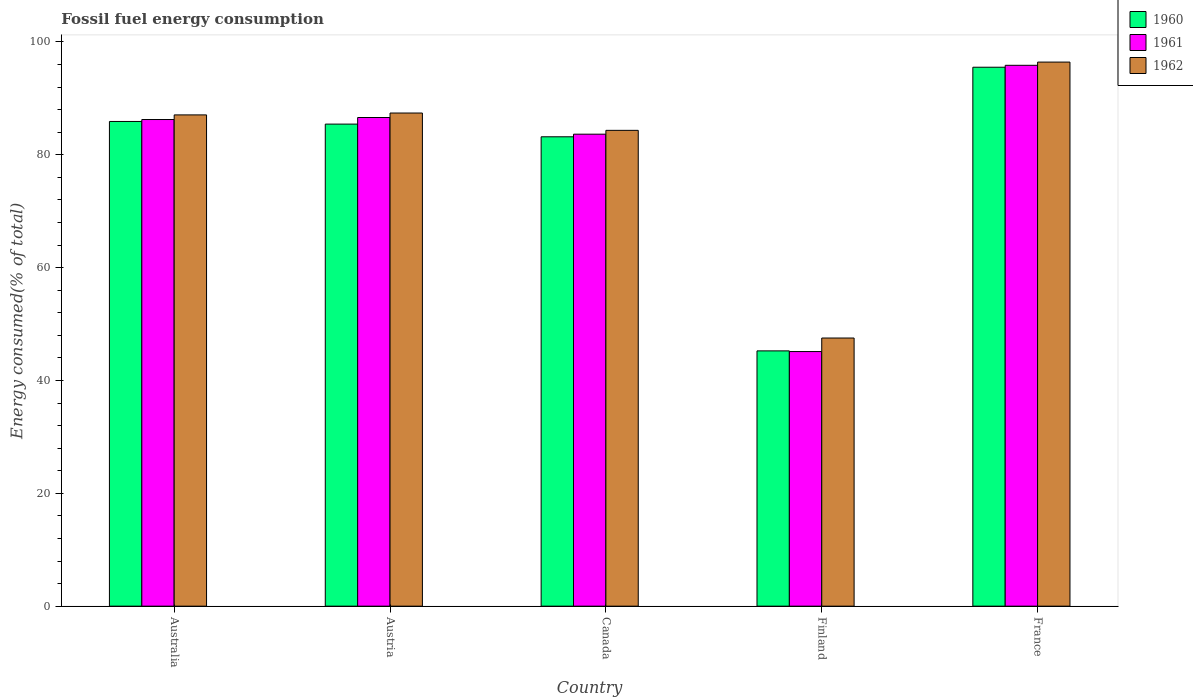How many different coloured bars are there?
Offer a very short reply. 3. Are the number of bars per tick equal to the number of legend labels?
Your response must be concise. Yes. What is the percentage of energy consumed in 1962 in France?
Your answer should be very brief. 96.43. Across all countries, what is the maximum percentage of energy consumed in 1961?
Offer a very short reply. 95.86. Across all countries, what is the minimum percentage of energy consumed in 1961?
Give a very brief answer. 45.13. In which country was the percentage of energy consumed in 1961 maximum?
Your answer should be compact. France. In which country was the percentage of energy consumed in 1962 minimum?
Offer a very short reply. Finland. What is the total percentage of energy consumed in 1960 in the graph?
Offer a terse response. 395.31. What is the difference between the percentage of energy consumed in 1962 in Canada and that in France?
Make the answer very short. -12.1. What is the difference between the percentage of energy consumed in 1960 in Finland and the percentage of energy consumed in 1962 in Australia?
Provide a succinct answer. -41.82. What is the average percentage of energy consumed in 1960 per country?
Your response must be concise. 79.06. What is the difference between the percentage of energy consumed of/in 1961 and percentage of energy consumed of/in 1960 in France?
Offer a terse response. 0.34. What is the ratio of the percentage of energy consumed in 1961 in Austria to that in Finland?
Give a very brief answer. 1.92. Is the percentage of energy consumed in 1962 in Australia less than that in Finland?
Provide a short and direct response. No. Is the difference between the percentage of energy consumed in 1961 in Austria and France greater than the difference between the percentage of energy consumed in 1960 in Austria and France?
Provide a short and direct response. Yes. What is the difference between the highest and the second highest percentage of energy consumed in 1960?
Keep it short and to the point. -0.47. What is the difference between the highest and the lowest percentage of energy consumed in 1962?
Offer a very short reply. 48.91. In how many countries, is the percentage of energy consumed in 1961 greater than the average percentage of energy consumed in 1961 taken over all countries?
Offer a terse response. 4. Is the sum of the percentage of energy consumed in 1960 in Australia and Finland greater than the maximum percentage of energy consumed in 1962 across all countries?
Make the answer very short. Yes. Is it the case that in every country, the sum of the percentage of energy consumed in 1961 and percentage of energy consumed in 1962 is greater than the percentage of energy consumed in 1960?
Offer a very short reply. Yes. How many bars are there?
Provide a short and direct response. 15. Are all the bars in the graph horizontal?
Provide a succinct answer. No. What is the difference between two consecutive major ticks on the Y-axis?
Your answer should be compact. 20. Does the graph contain grids?
Keep it short and to the point. No. Where does the legend appear in the graph?
Offer a very short reply. Top right. How are the legend labels stacked?
Your answer should be compact. Vertical. What is the title of the graph?
Your answer should be very brief. Fossil fuel energy consumption. What is the label or title of the Y-axis?
Ensure brevity in your answer.  Energy consumed(% of total). What is the Energy consumed(% of total) in 1960 in Australia?
Keep it short and to the point. 85.91. What is the Energy consumed(% of total) in 1961 in Australia?
Provide a succinct answer. 86.25. What is the Energy consumed(% of total) of 1962 in Australia?
Your answer should be compact. 87.07. What is the Energy consumed(% of total) in 1960 in Austria?
Provide a succinct answer. 85.44. What is the Energy consumed(% of total) of 1961 in Austria?
Provide a short and direct response. 86.61. What is the Energy consumed(% of total) in 1962 in Austria?
Keep it short and to the point. 87.4. What is the Energy consumed(% of total) in 1960 in Canada?
Ensure brevity in your answer.  83.19. What is the Energy consumed(% of total) in 1961 in Canada?
Give a very brief answer. 83.65. What is the Energy consumed(% of total) in 1962 in Canada?
Offer a very short reply. 84.33. What is the Energy consumed(% of total) of 1960 in Finland?
Your response must be concise. 45.25. What is the Energy consumed(% of total) of 1961 in Finland?
Your answer should be very brief. 45.13. What is the Energy consumed(% of total) of 1962 in Finland?
Ensure brevity in your answer.  47.52. What is the Energy consumed(% of total) in 1960 in France?
Ensure brevity in your answer.  95.52. What is the Energy consumed(% of total) in 1961 in France?
Your response must be concise. 95.86. What is the Energy consumed(% of total) of 1962 in France?
Your response must be concise. 96.43. Across all countries, what is the maximum Energy consumed(% of total) in 1960?
Keep it short and to the point. 95.52. Across all countries, what is the maximum Energy consumed(% of total) in 1961?
Keep it short and to the point. 95.86. Across all countries, what is the maximum Energy consumed(% of total) of 1962?
Keep it short and to the point. 96.43. Across all countries, what is the minimum Energy consumed(% of total) in 1960?
Your answer should be compact. 45.25. Across all countries, what is the minimum Energy consumed(% of total) in 1961?
Your answer should be very brief. 45.13. Across all countries, what is the minimum Energy consumed(% of total) in 1962?
Provide a succinct answer. 47.52. What is the total Energy consumed(% of total) in 1960 in the graph?
Your answer should be very brief. 395.31. What is the total Energy consumed(% of total) of 1961 in the graph?
Your answer should be compact. 397.51. What is the total Energy consumed(% of total) in 1962 in the graph?
Provide a succinct answer. 402.76. What is the difference between the Energy consumed(% of total) in 1960 in Australia and that in Austria?
Provide a short and direct response. 0.47. What is the difference between the Energy consumed(% of total) of 1961 in Australia and that in Austria?
Your response must be concise. -0.36. What is the difference between the Energy consumed(% of total) of 1962 in Australia and that in Austria?
Your answer should be very brief. -0.33. What is the difference between the Energy consumed(% of total) in 1960 in Australia and that in Canada?
Provide a succinct answer. 2.71. What is the difference between the Energy consumed(% of total) in 1961 in Australia and that in Canada?
Provide a succinct answer. 2.6. What is the difference between the Energy consumed(% of total) of 1962 in Australia and that in Canada?
Give a very brief answer. 2.74. What is the difference between the Energy consumed(% of total) in 1960 in Australia and that in Finland?
Provide a short and direct response. 40.66. What is the difference between the Energy consumed(% of total) in 1961 in Australia and that in Finland?
Your answer should be very brief. 41.12. What is the difference between the Energy consumed(% of total) in 1962 in Australia and that in Finland?
Offer a very short reply. 39.55. What is the difference between the Energy consumed(% of total) of 1960 in Australia and that in France?
Make the answer very short. -9.61. What is the difference between the Energy consumed(% of total) of 1961 in Australia and that in France?
Provide a short and direct response. -9.61. What is the difference between the Energy consumed(% of total) in 1962 in Australia and that in France?
Your answer should be very brief. -9.36. What is the difference between the Energy consumed(% of total) in 1960 in Austria and that in Canada?
Your answer should be very brief. 2.25. What is the difference between the Energy consumed(% of total) in 1961 in Austria and that in Canada?
Keep it short and to the point. 2.95. What is the difference between the Energy consumed(% of total) in 1962 in Austria and that in Canada?
Provide a short and direct response. 3.07. What is the difference between the Energy consumed(% of total) of 1960 in Austria and that in Finland?
Your response must be concise. 40.19. What is the difference between the Energy consumed(% of total) in 1961 in Austria and that in Finland?
Provide a succinct answer. 41.48. What is the difference between the Energy consumed(% of total) in 1962 in Austria and that in Finland?
Offer a very short reply. 39.88. What is the difference between the Energy consumed(% of total) of 1960 in Austria and that in France?
Your response must be concise. -10.08. What is the difference between the Energy consumed(% of total) in 1961 in Austria and that in France?
Offer a very short reply. -9.25. What is the difference between the Energy consumed(% of total) in 1962 in Austria and that in France?
Keep it short and to the point. -9.03. What is the difference between the Energy consumed(% of total) of 1960 in Canada and that in Finland?
Your answer should be very brief. 37.95. What is the difference between the Energy consumed(% of total) of 1961 in Canada and that in Finland?
Keep it short and to the point. 38.53. What is the difference between the Energy consumed(% of total) of 1962 in Canada and that in Finland?
Your response must be concise. 36.81. What is the difference between the Energy consumed(% of total) of 1960 in Canada and that in France?
Offer a very short reply. -12.33. What is the difference between the Energy consumed(% of total) of 1961 in Canada and that in France?
Make the answer very short. -12.21. What is the difference between the Energy consumed(% of total) of 1962 in Canada and that in France?
Provide a succinct answer. -12.1. What is the difference between the Energy consumed(% of total) of 1960 in Finland and that in France?
Your response must be concise. -50.27. What is the difference between the Energy consumed(% of total) in 1961 in Finland and that in France?
Make the answer very short. -50.73. What is the difference between the Energy consumed(% of total) in 1962 in Finland and that in France?
Give a very brief answer. -48.91. What is the difference between the Energy consumed(% of total) in 1960 in Australia and the Energy consumed(% of total) in 1961 in Austria?
Offer a terse response. -0.7. What is the difference between the Energy consumed(% of total) of 1960 in Australia and the Energy consumed(% of total) of 1962 in Austria?
Your answer should be very brief. -1.5. What is the difference between the Energy consumed(% of total) in 1961 in Australia and the Energy consumed(% of total) in 1962 in Austria?
Provide a succinct answer. -1.15. What is the difference between the Energy consumed(% of total) of 1960 in Australia and the Energy consumed(% of total) of 1961 in Canada?
Your response must be concise. 2.25. What is the difference between the Energy consumed(% of total) of 1960 in Australia and the Energy consumed(% of total) of 1962 in Canada?
Your response must be concise. 1.57. What is the difference between the Energy consumed(% of total) in 1961 in Australia and the Energy consumed(% of total) in 1962 in Canada?
Ensure brevity in your answer.  1.92. What is the difference between the Energy consumed(% of total) in 1960 in Australia and the Energy consumed(% of total) in 1961 in Finland?
Ensure brevity in your answer.  40.78. What is the difference between the Energy consumed(% of total) of 1960 in Australia and the Energy consumed(% of total) of 1962 in Finland?
Offer a very short reply. 38.38. What is the difference between the Energy consumed(% of total) in 1961 in Australia and the Energy consumed(% of total) in 1962 in Finland?
Give a very brief answer. 38.73. What is the difference between the Energy consumed(% of total) of 1960 in Australia and the Energy consumed(% of total) of 1961 in France?
Ensure brevity in your answer.  -9.96. What is the difference between the Energy consumed(% of total) in 1960 in Australia and the Energy consumed(% of total) in 1962 in France?
Provide a succinct answer. -10.53. What is the difference between the Energy consumed(% of total) of 1961 in Australia and the Energy consumed(% of total) of 1962 in France?
Your answer should be compact. -10.18. What is the difference between the Energy consumed(% of total) of 1960 in Austria and the Energy consumed(% of total) of 1961 in Canada?
Offer a very short reply. 1.79. What is the difference between the Energy consumed(% of total) of 1960 in Austria and the Energy consumed(% of total) of 1962 in Canada?
Provide a succinct answer. 1.11. What is the difference between the Energy consumed(% of total) in 1961 in Austria and the Energy consumed(% of total) in 1962 in Canada?
Your answer should be compact. 2.28. What is the difference between the Energy consumed(% of total) of 1960 in Austria and the Energy consumed(% of total) of 1961 in Finland?
Keep it short and to the point. 40.31. What is the difference between the Energy consumed(% of total) in 1960 in Austria and the Energy consumed(% of total) in 1962 in Finland?
Ensure brevity in your answer.  37.92. What is the difference between the Energy consumed(% of total) in 1961 in Austria and the Energy consumed(% of total) in 1962 in Finland?
Provide a succinct answer. 39.08. What is the difference between the Energy consumed(% of total) of 1960 in Austria and the Energy consumed(% of total) of 1961 in France?
Provide a short and direct response. -10.42. What is the difference between the Energy consumed(% of total) in 1960 in Austria and the Energy consumed(% of total) in 1962 in France?
Keep it short and to the point. -10.99. What is the difference between the Energy consumed(% of total) of 1961 in Austria and the Energy consumed(% of total) of 1962 in France?
Ensure brevity in your answer.  -9.82. What is the difference between the Energy consumed(% of total) in 1960 in Canada and the Energy consumed(% of total) in 1961 in Finland?
Your answer should be compact. 38.06. What is the difference between the Energy consumed(% of total) of 1960 in Canada and the Energy consumed(% of total) of 1962 in Finland?
Your response must be concise. 35.67. What is the difference between the Energy consumed(% of total) of 1961 in Canada and the Energy consumed(% of total) of 1962 in Finland?
Your response must be concise. 36.13. What is the difference between the Energy consumed(% of total) of 1960 in Canada and the Energy consumed(% of total) of 1961 in France?
Your answer should be very brief. -12.67. What is the difference between the Energy consumed(% of total) in 1960 in Canada and the Energy consumed(% of total) in 1962 in France?
Give a very brief answer. -13.24. What is the difference between the Energy consumed(% of total) in 1961 in Canada and the Energy consumed(% of total) in 1962 in France?
Offer a very short reply. -12.78. What is the difference between the Energy consumed(% of total) in 1960 in Finland and the Energy consumed(% of total) in 1961 in France?
Provide a short and direct response. -50.62. What is the difference between the Energy consumed(% of total) of 1960 in Finland and the Energy consumed(% of total) of 1962 in France?
Make the answer very short. -51.19. What is the difference between the Energy consumed(% of total) in 1961 in Finland and the Energy consumed(% of total) in 1962 in France?
Keep it short and to the point. -51.3. What is the average Energy consumed(% of total) in 1960 per country?
Your response must be concise. 79.06. What is the average Energy consumed(% of total) in 1961 per country?
Your answer should be very brief. 79.5. What is the average Energy consumed(% of total) in 1962 per country?
Offer a very short reply. 80.55. What is the difference between the Energy consumed(% of total) in 1960 and Energy consumed(% of total) in 1961 in Australia?
Ensure brevity in your answer.  -0.35. What is the difference between the Energy consumed(% of total) of 1960 and Energy consumed(% of total) of 1962 in Australia?
Your response must be concise. -1.16. What is the difference between the Energy consumed(% of total) of 1961 and Energy consumed(% of total) of 1962 in Australia?
Offer a terse response. -0.82. What is the difference between the Energy consumed(% of total) in 1960 and Energy consumed(% of total) in 1961 in Austria?
Provide a succinct answer. -1.17. What is the difference between the Energy consumed(% of total) in 1960 and Energy consumed(% of total) in 1962 in Austria?
Give a very brief answer. -1.96. What is the difference between the Energy consumed(% of total) in 1961 and Energy consumed(% of total) in 1962 in Austria?
Provide a short and direct response. -0.79. What is the difference between the Energy consumed(% of total) in 1960 and Energy consumed(% of total) in 1961 in Canada?
Give a very brief answer. -0.46. What is the difference between the Energy consumed(% of total) of 1960 and Energy consumed(% of total) of 1962 in Canada?
Keep it short and to the point. -1.14. What is the difference between the Energy consumed(% of total) of 1961 and Energy consumed(% of total) of 1962 in Canada?
Your answer should be very brief. -0.68. What is the difference between the Energy consumed(% of total) in 1960 and Energy consumed(% of total) in 1961 in Finland?
Offer a terse response. 0.12. What is the difference between the Energy consumed(% of total) in 1960 and Energy consumed(% of total) in 1962 in Finland?
Offer a very short reply. -2.28. What is the difference between the Energy consumed(% of total) in 1961 and Energy consumed(% of total) in 1962 in Finland?
Provide a succinct answer. -2.4. What is the difference between the Energy consumed(% of total) of 1960 and Energy consumed(% of total) of 1961 in France?
Your response must be concise. -0.34. What is the difference between the Energy consumed(% of total) of 1960 and Energy consumed(% of total) of 1962 in France?
Keep it short and to the point. -0.91. What is the difference between the Energy consumed(% of total) in 1961 and Energy consumed(% of total) in 1962 in France?
Provide a short and direct response. -0.57. What is the ratio of the Energy consumed(% of total) in 1960 in Australia to that in Austria?
Your answer should be compact. 1.01. What is the ratio of the Energy consumed(% of total) of 1960 in Australia to that in Canada?
Make the answer very short. 1.03. What is the ratio of the Energy consumed(% of total) of 1961 in Australia to that in Canada?
Provide a short and direct response. 1.03. What is the ratio of the Energy consumed(% of total) in 1962 in Australia to that in Canada?
Provide a succinct answer. 1.03. What is the ratio of the Energy consumed(% of total) of 1960 in Australia to that in Finland?
Provide a succinct answer. 1.9. What is the ratio of the Energy consumed(% of total) in 1961 in Australia to that in Finland?
Provide a short and direct response. 1.91. What is the ratio of the Energy consumed(% of total) of 1962 in Australia to that in Finland?
Offer a very short reply. 1.83. What is the ratio of the Energy consumed(% of total) of 1960 in Australia to that in France?
Keep it short and to the point. 0.9. What is the ratio of the Energy consumed(% of total) of 1961 in Australia to that in France?
Your answer should be very brief. 0.9. What is the ratio of the Energy consumed(% of total) of 1962 in Australia to that in France?
Make the answer very short. 0.9. What is the ratio of the Energy consumed(% of total) of 1960 in Austria to that in Canada?
Ensure brevity in your answer.  1.03. What is the ratio of the Energy consumed(% of total) of 1961 in Austria to that in Canada?
Your answer should be compact. 1.04. What is the ratio of the Energy consumed(% of total) of 1962 in Austria to that in Canada?
Your answer should be very brief. 1.04. What is the ratio of the Energy consumed(% of total) of 1960 in Austria to that in Finland?
Keep it short and to the point. 1.89. What is the ratio of the Energy consumed(% of total) of 1961 in Austria to that in Finland?
Your response must be concise. 1.92. What is the ratio of the Energy consumed(% of total) of 1962 in Austria to that in Finland?
Give a very brief answer. 1.84. What is the ratio of the Energy consumed(% of total) of 1960 in Austria to that in France?
Provide a short and direct response. 0.89. What is the ratio of the Energy consumed(% of total) of 1961 in Austria to that in France?
Your answer should be compact. 0.9. What is the ratio of the Energy consumed(% of total) of 1962 in Austria to that in France?
Your answer should be compact. 0.91. What is the ratio of the Energy consumed(% of total) in 1960 in Canada to that in Finland?
Keep it short and to the point. 1.84. What is the ratio of the Energy consumed(% of total) of 1961 in Canada to that in Finland?
Your response must be concise. 1.85. What is the ratio of the Energy consumed(% of total) of 1962 in Canada to that in Finland?
Your answer should be very brief. 1.77. What is the ratio of the Energy consumed(% of total) of 1960 in Canada to that in France?
Offer a terse response. 0.87. What is the ratio of the Energy consumed(% of total) of 1961 in Canada to that in France?
Your answer should be very brief. 0.87. What is the ratio of the Energy consumed(% of total) in 1962 in Canada to that in France?
Make the answer very short. 0.87. What is the ratio of the Energy consumed(% of total) of 1960 in Finland to that in France?
Your response must be concise. 0.47. What is the ratio of the Energy consumed(% of total) of 1961 in Finland to that in France?
Give a very brief answer. 0.47. What is the ratio of the Energy consumed(% of total) of 1962 in Finland to that in France?
Keep it short and to the point. 0.49. What is the difference between the highest and the second highest Energy consumed(% of total) in 1960?
Your answer should be compact. 9.61. What is the difference between the highest and the second highest Energy consumed(% of total) in 1961?
Give a very brief answer. 9.25. What is the difference between the highest and the second highest Energy consumed(% of total) in 1962?
Give a very brief answer. 9.03. What is the difference between the highest and the lowest Energy consumed(% of total) of 1960?
Provide a short and direct response. 50.27. What is the difference between the highest and the lowest Energy consumed(% of total) of 1961?
Offer a very short reply. 50.73. What is the difference between the highest and the lowest Energy consumed(% of total) of 1962?
Your answer should be compact. 48.91. 